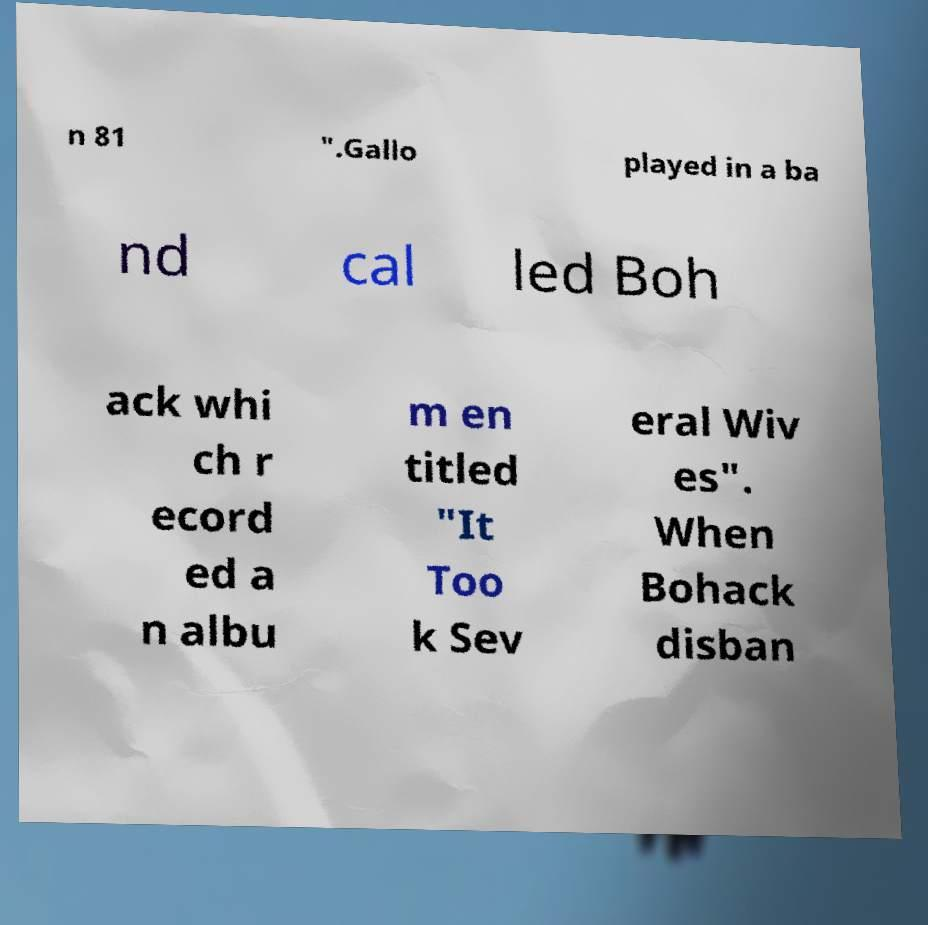For documentation purposes, I need the text within this image transcribed. Could you provide that? n 81 ".Gallo played in a ba nd cal led Boh ack whi ch r ecord ed a n albu m en titled "It Too k Sev eral Wiv es". When Bohack disban 